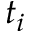Convert formula to latex. <formula><loc_0><loc_0><loc_500><loc_500>t _ { i }</formula> 